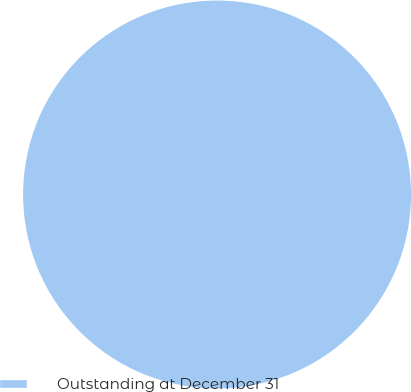<chart> <loc_0><loc_0><loc_500><loc_500><pie_chart><fcel>Outstanding at December 31<nl><fcel>100.0%<nl></chart> 